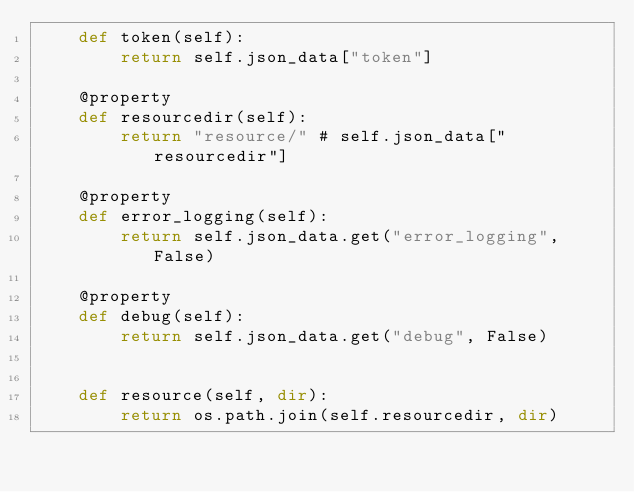Convert code to text. <code><loc_0><loc_0><loc_500><loc_500><_Python_>	def token(self):
		return self.json_data["token"]

	@property
	def resourcedir(self):
		return "resource/" # self.json_data["resourcedir"]

	@property
	def error_logging(self):
		return self.json_data.get("error_logging", False)

	@property
	def debug(self):
	    return self.json_data.get("debug", False)
	

	def resource(self, dir):
		return os.path.join(self.resourcedir, dir)

</code> 